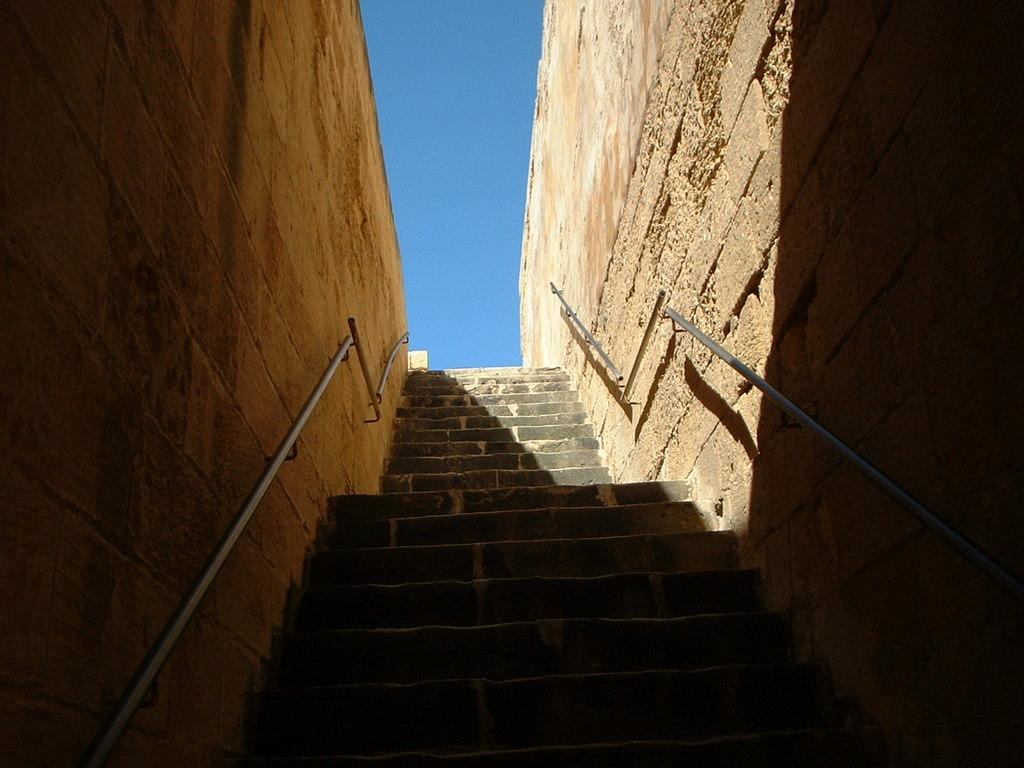What celestial objects can be seen in the image? There are stars visible in the image. What type of architectural feature is present in the image? There are staircase holders attached to the walls in the image. What can be seen in the background of the image? The sky is visible in the background of the image. What type of twig is being used as a match in the image? There is no twig or match present in the image. What type of food is being served in the image? There is no food present in the image. 